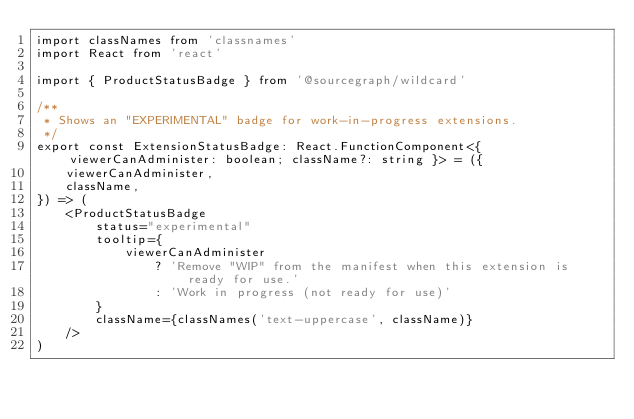Convert code to text. <code><loc_0><loc_0><loc_500><loc_500><_TypeScript_>import classNames from 'classnames'
import React from 'react'

import { ProductStatusBadge } from '@sourcegraph/wildcard'

/**
 * Shows an "EXPERIMENTAL" badge for work-in-progress extensions.
 */
export const ExtensionStatusBadge: React.FunctionComponent<{ viewerCanAdminister: boolean; className?: string }> = ({
    viewerCanAdminister,
    className,
}) => (
    <ProductStatusBadge
        status="experimental"
        tooltip={
            viewerCanAdminister
                ? 'Remove "WIP" from the manifest when this extension is ready for use.'
                : 'Work in progress (not ready for use)'
        }
        className={classNames('text-uppercase', className)}
    />
)
</code> 